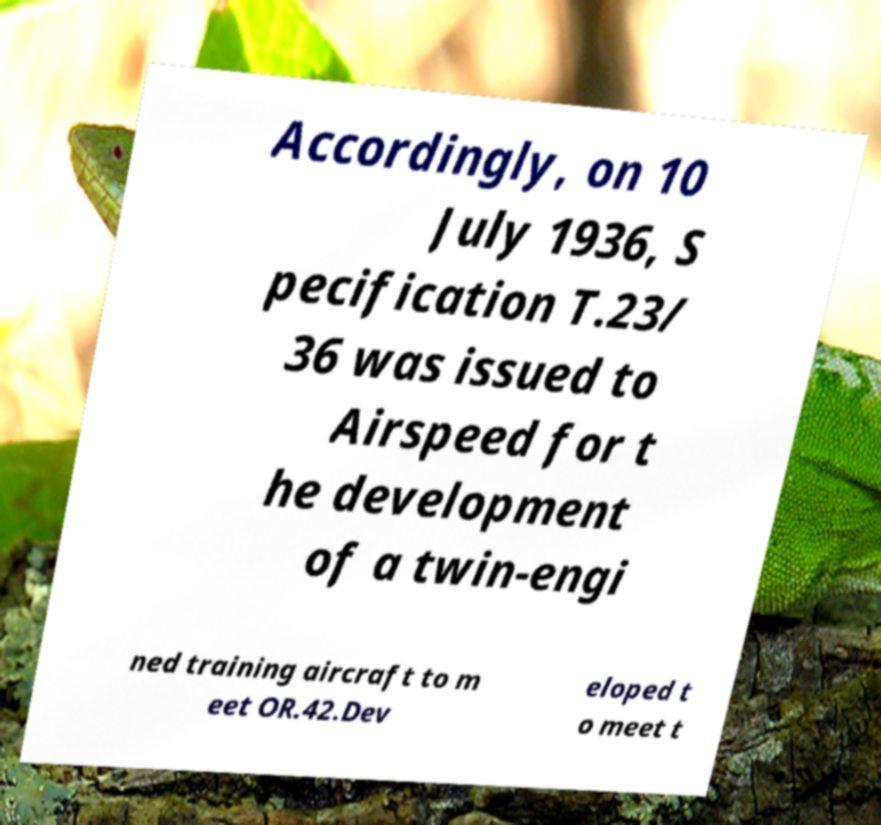What messages or text are displayed in this image? I need them in a readable, typed format. Accordingly, on 10 July 1936, S pecification T.23/ 36 was issued to Airspeed for t he development of a twin-engi ned training aircraft to m eet OR.42.Dev eloped t o meet t 